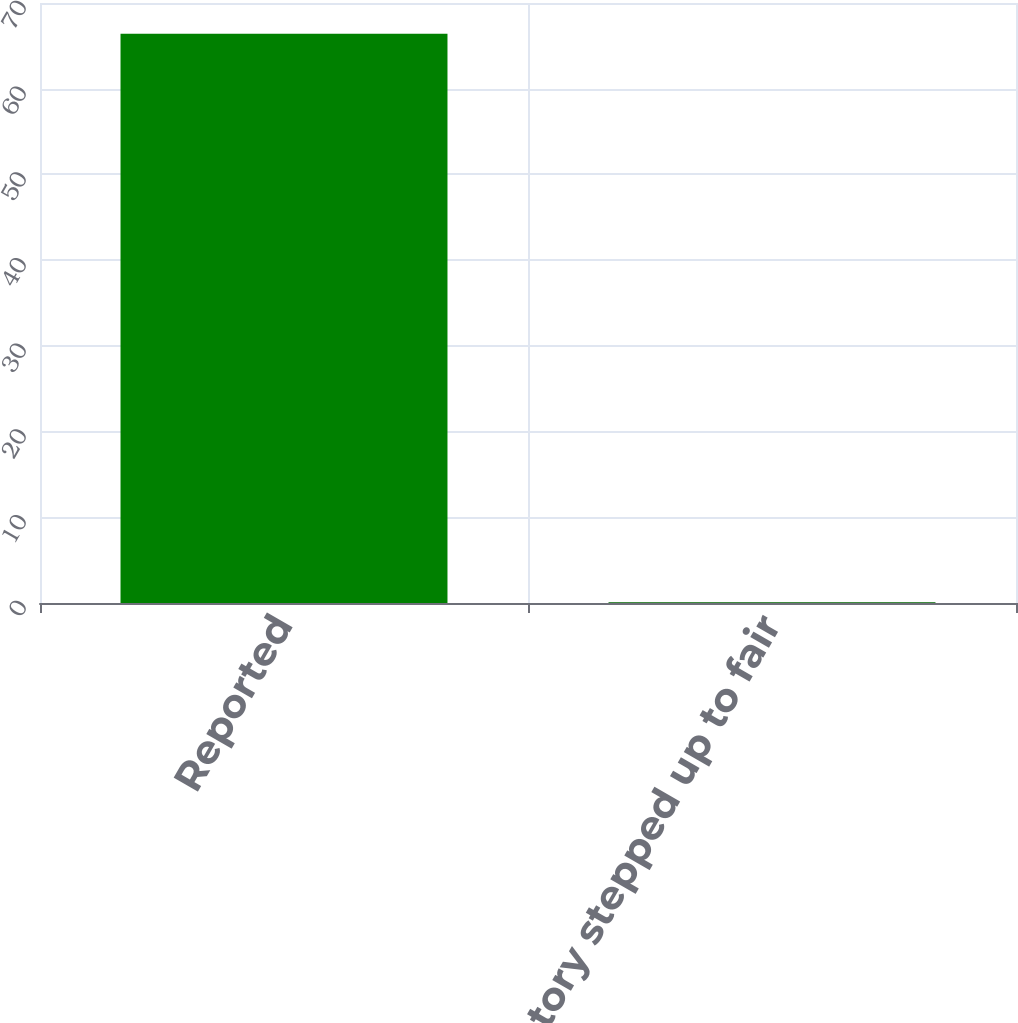<chart> <loc_0><loc_0><loc_500><loc_500><bar_chart><fcel>Reported<fcel>Inventory stepped up to fair<nl><fcel>66.4<fcel>0.1<nl></chart> 